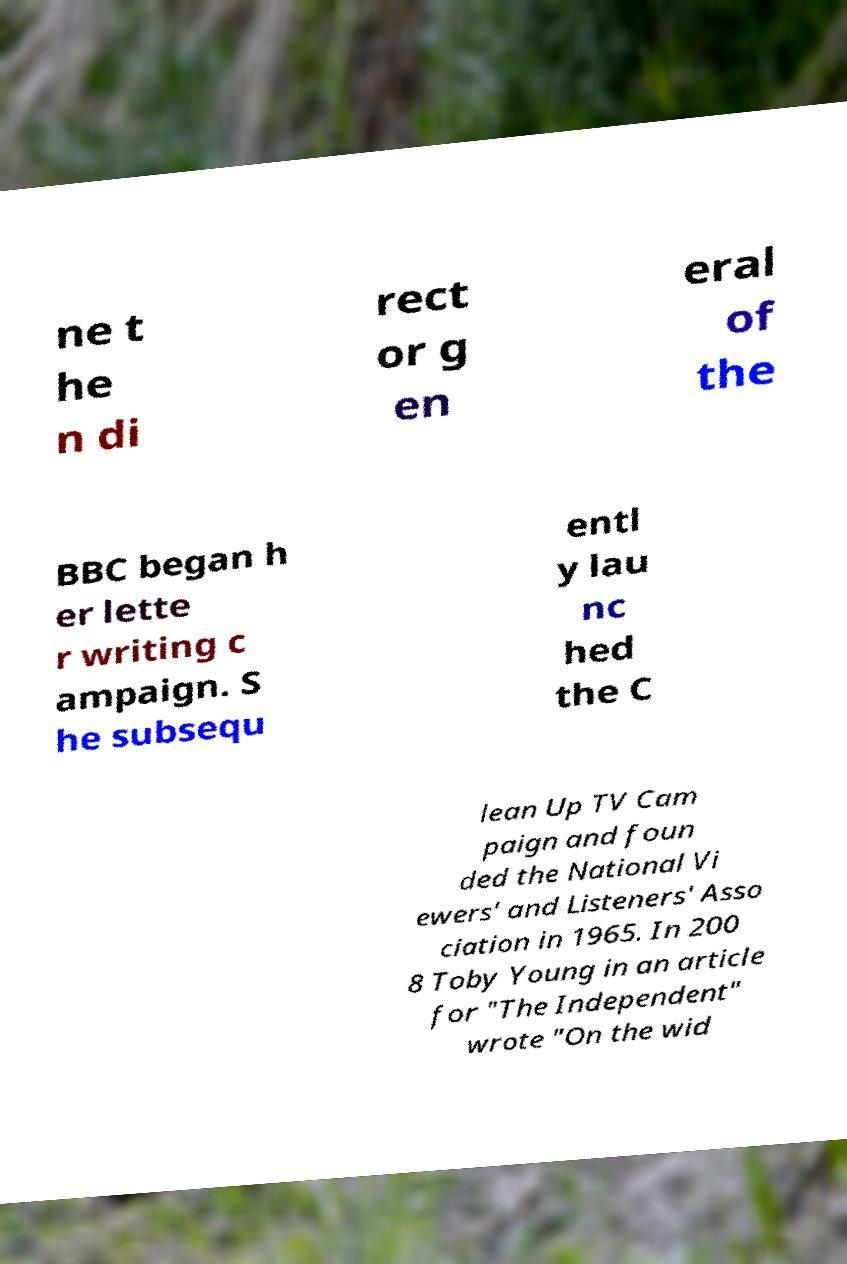Can you read and provide the text displayed in the image?This photo seems to have some interesting text. Can you extract and type it out for me? ne t he n di rect or g en eral of the BBC began h er lette r writing c ampaign. S he subsequ entl y lau nc hed the C lean Up TV Cam paign and foun ded the National Vi ewers' and Listeners' Asso ciation in 1965. In 200 8 Toby Young in an article for "The Independent" wrote "On the wid 